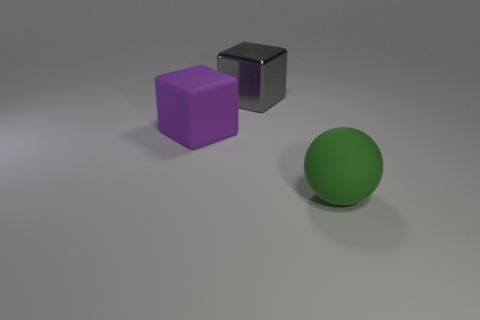Are there any other things that are the same material as the gray thing?
Provide a short and direct response. No. There is a cube that is in front of the large gray metallic thing; what is its material?
Your response must be concise. Rubber. What is the shape of the thing that is in front of the large shiny thing and on the right side of the big rubber cube?
Provide a short and direct response. Sphere. What is the material of the purple thing?
Your answer should be compact. Rubber. What number of blocks are either gray rubber objects or big purple things?
Make the answer very short. 1. Are the large purple block and the large sphere made of the same material?
Your response must be concise. Yes. There is another object that is the same shape as the big purple thing; what size is it?
Offer a terse response. Large. There is a object that is both in front of the big gray metallic cube and on the right side of the large purple object; what material is it?
Your response must be concise. Rubber. Is the number of large matte things behind the large purple thing the same as the number of yellow objects?
Provide a succinct answer. Yes. What number of objects are either large matte objects that are to the left of the green ball or metallic balls?
Provide a short and direct response. 1. 